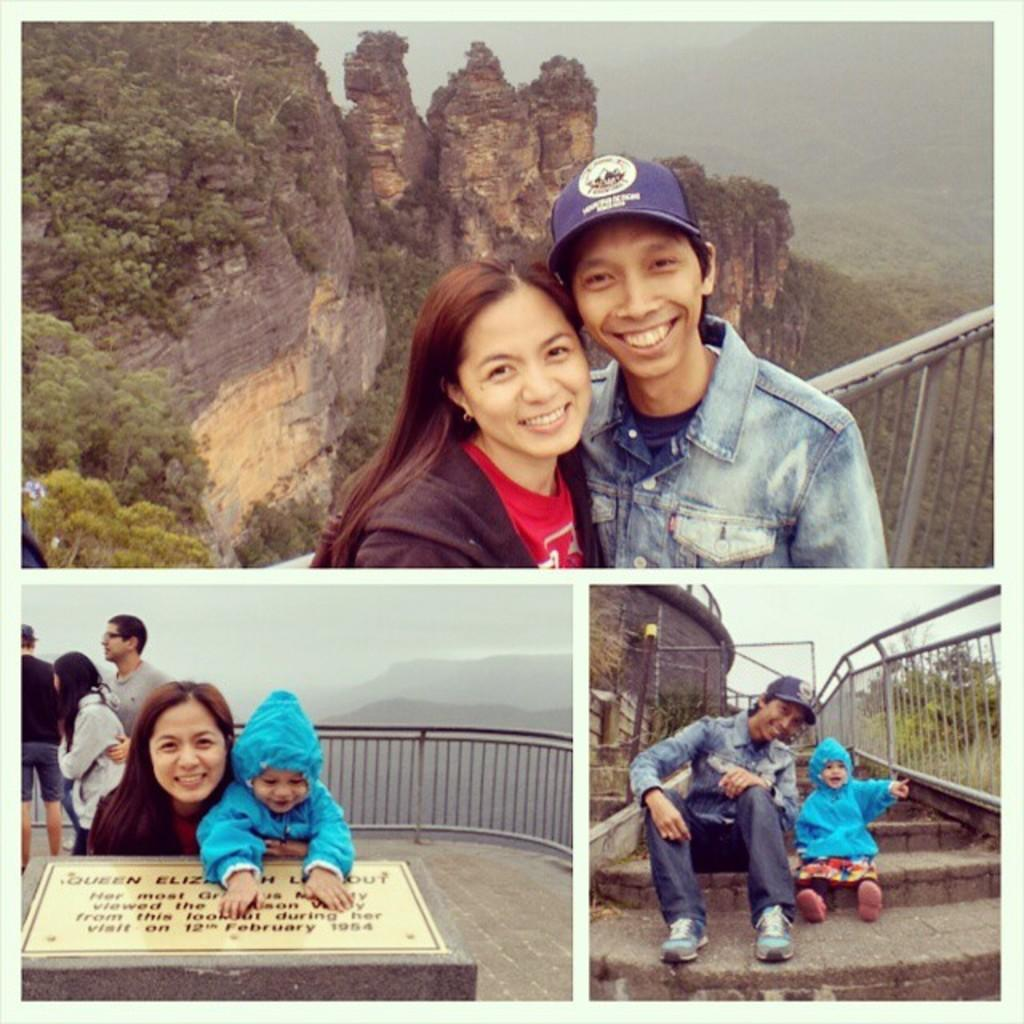How many people are in the group visible in the image? There is a group of people in the image, but the exact number cannot be determined from the provided facts. What is the purpose of the memorial in the image? The purpose of the memorial cannot be determined from the provided facts. What is the fence used for in the image? The purpose of the fence cannot be determined from the provided facts. How many steps are visible in the image? There are steps in the image, but the exact number cannot be determined from the provided facts. What type of trees are present in the image? The type of trees cannot be determined from the provided facts. What is the distance between the mountains in the image? The distance between the mountains cannot be determined from the provided facts. What is visible in the sky in the image? The sky is visible in the image, but the specific conditions or elements cannot be determined from the provided facts. How does the society in the image react to the point made by the speaker? There is no speaker or society present in the image, so it is not possible to answer this question. 